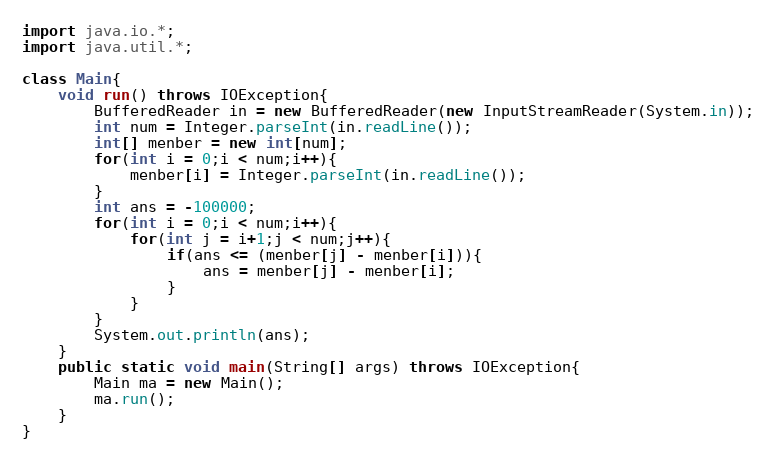<code> <loc_0><loc_0><loc_500><loc_500><_Java_>import java.io.*;
import java.util.*;

class Main{
    void run() throws IOException{
        BufferedReader in = new BufferedReader(new InputStreamReader(System.in));
        int num = Integer.parseInt(in.readLine());
        int[] menber = new int[num];
        for(int i = 0;i < num;i++){
            menber[i] = Integer.parseInt(in.readLine());
        }
        int ans = -100000;
        for(int i = 0;i < num;i++){
            for(int j = i+1;j < num;j++){
                if(ans <= (menber[j] - menber[i])){
                    ans = menber[j] - menber[i];
                }
            }
        }
        System.out.println(ans);
    }
    public static void main(String[] args) throws IOException{
        Main ma = new Main();
        ma.run();
    }
}</code> 